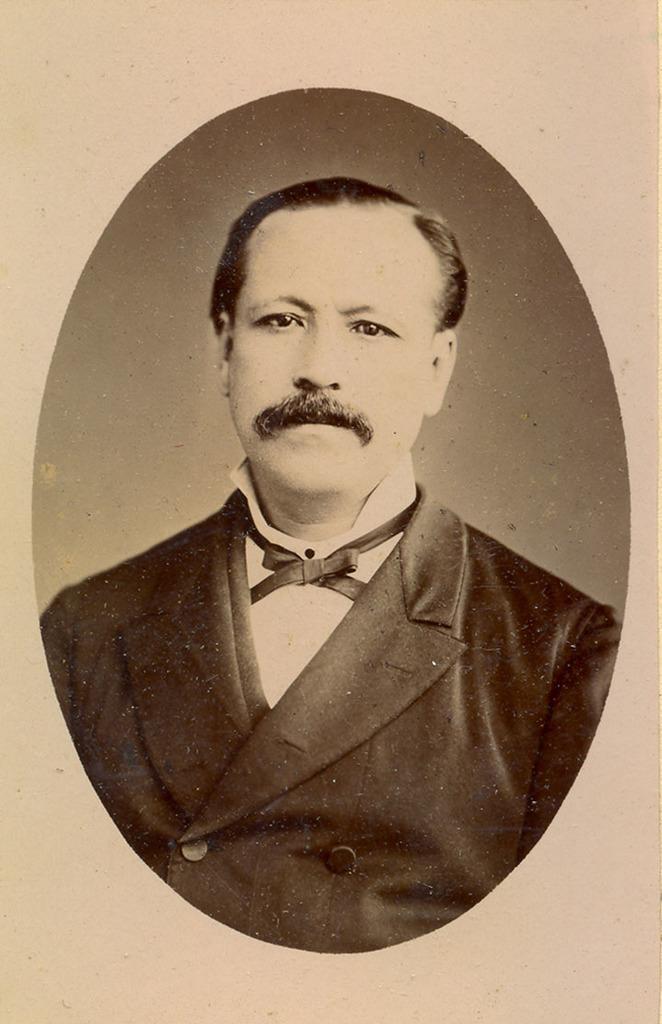Please provide a concise description of this image. This is a paper and in the center of the image, we can see a sketch of a person. 